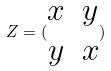Convert formula to latex. <formula><loc_0><loc_0><loc_500><loc_500>Z = ( \begin{matrix} x & y \\ y & x \end{matrix} )</formula> 